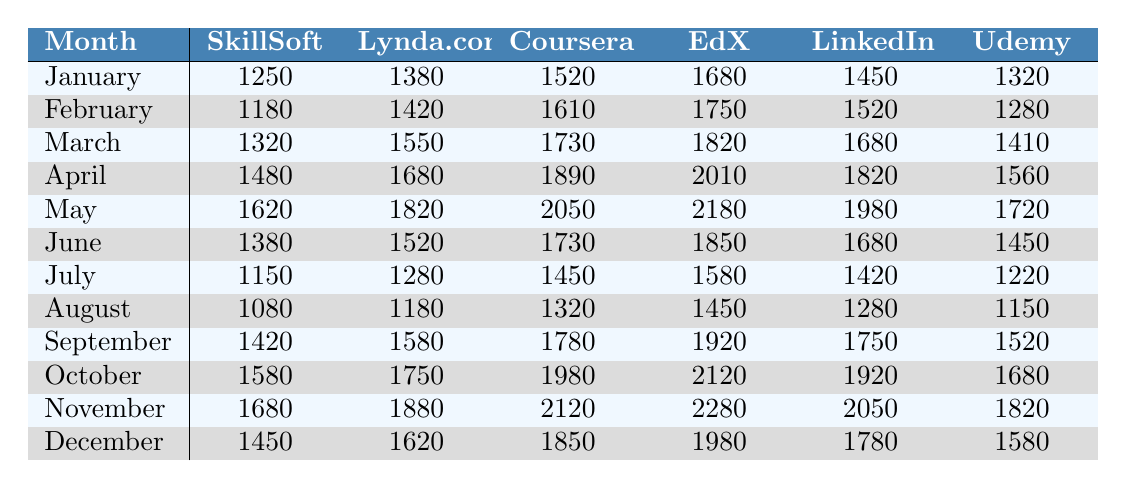What is the usage statistic for SkillSoft in March? The table shows the usage statistics under the SkillSoft column for March, which is listed as 1320.
Answer: 1320 Which database had the highest usage in May? In May, the values for each database are: SkillSoft (1620), Lynda.com (1820), Coursera (2050), EdX (2180), LinkedIn (1980), and Udemy (1720). EdX has the highest value at 2180.
Answer: EdX What is the average usage for Coursera for the first half of the year (January to June)? The first half values for Coursera are: 1520 (January), 1610 (February), 1730 (March), 1890 (April), 2050 (May), and 1730 (June). Their sum is 1520 + 1610 + 1730 + 1890 + 2050 + 1730 = 11530. Dividing by 6 gives an average of 1921.67, which rounds to 1922.
Answer: 1922 Did Lynda.com usage increase or decrease from January to December? For Lynda.com, usage in January is 1380 and in December is 1620. Since 1620 is greater than 1380, it indicates an increase.
Answer: Increase What was the growth rate of usage for LinkedIn Learning from January to November? The usage for LinkedIn Learning in January is 1450 and in November is 2050. The growth is calculated as (2050 - 1450) / 1450 * 100 = 41.38%, indicating a significant growth of about 41.38%.
Answer: 41.38% Identify the month with the lowest usage for Udemy. Checking the Udemy column, the values for each month are: 1320 (January), 1280 (February), 1410 (March), 1560 (April), 1720 (May), 1450 (June), 1220 (July), 1150 (August), 1520 (September), 1680 (October), 1820 (November), and 1580 (December). The minimum value is 1150 in August.
Answer: August Which database had the lowest usage in July? In July, the usage stats are: SkillSoft (1150), Lynda.com (1280), Coursera (1450), EdX (1580), LinkedIn (1420), and Udemy (1220). The database with the lowest usage is SkillSoft at 1150.
Answer: SkillSoft What is the difference in usage between the highest and lowest months for EdX? The highest usage for EdX is in May (2180) and the lowest is in August (1450). The difference is 2180 - 1450 = 730.
Answer: 730 Which month had the second highest overall database usage? The total monthly usage for each month is calculated, with November being the highest at 12680 and May being the second highest at 11520.
Answer: May On which months did LinkedIn Learning have usage below 1500? Looking at the LinkedIn column, the usage values are: 1450 (January), 1520 (February), 1680 (March), 1820 (April), 1980 (May), 1680 (June), 1420 (July), 1280 (August), 1750 (September), 1920 (October), 2050 (November), and 1780 (December). LinkedIn Learning was below 1500 in January (1450) and July (1420).
Answer: January and July 